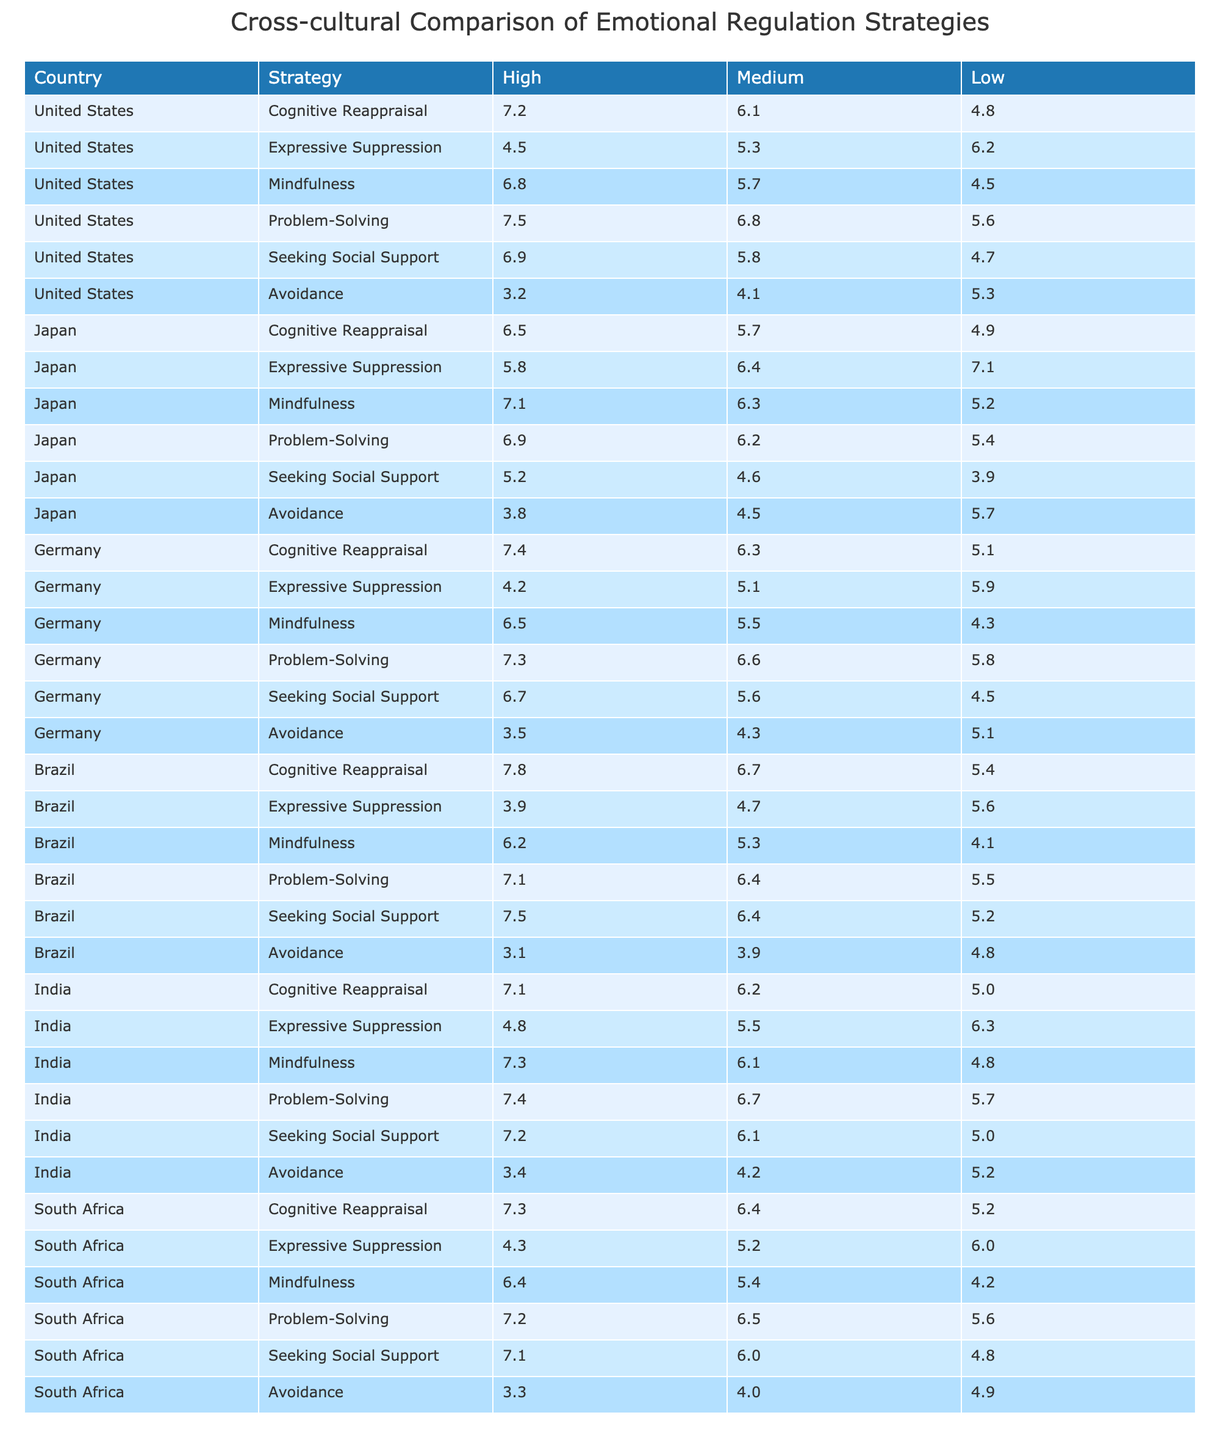What is the highest cognitive reappraisal score among countries for high empathy levels? The highest cognitive reappraisal score for high empathy is from Brazil with a score of 7.8.
Answer: 7.8 Which country shows the lowest score in expressive suppression for medium empathy? Japan has the lowest score in expressive suppression for medium empathy at 6.4.
Answer: 6.4 What is the average mindfulness score for high empathy across all countries? To find the average mindfulness score, add the high empathy scores: (6.8 + 7.1 + 6.5 + 6.2 + 7.3 + 7.8) = 41.7. Divide by 6: 41.7 / 6 = 6.95.
Answer: 6.95 Which emotional regulation strategy has the lowest average score for low empathy across all countries? For low empathy, the average scores are: Cognitive Reappraisal (5.1), Expressive Suppression (5.5), Mindfulness (4.9), Problem-Solving (5.3), Seeking Social Support (4.5), Avoidance (5.2). The lowest is Mindfulness at 4.9.
Answer: Mindfulness Is it true that Germany has a higher problem-solving score than the United States at medium empathy? Germany's medium problem-solving score is 6.6, while the United States' score is 6.8, which means it is false.
Answer: False What is the difference in seeking social support scores between high and low empathy for Brazil? For Brazil, high empathy seeking social support score is 7.5 and low empathy is 5.2. The difference is 7.5 - 5.2 = 2.3.
Answer: 2.3 Which country has the highest avoidance score for low empathy? For low empathy, the scores are: United States (5.3), Japan (5.7), Germany (5.1), Brazil (4.8), India (5.2), South Africa (4.9). Japan has the highest at 5.7.
Answer: Japan Is the average cognitive reappraisal score for high empathy higher or lower in South Africa compared to Japan? South Africa has a score of 7.3 and Japan has 6.5. Since 7.3 is higher than 6.5, the answer is higher.
Answer: Higher What strategy has the most consistent scores across empathy levels in the United States? Reviewing the United States scores: Cognitive Reappraisal (7.2, 6.1, 4.8), Expressive Suppression (4.5, 5.3, 6.2), Mindfulness (6.8, 5.7, 4.5), Problem-Solving (7.5, 6.8, 5.6), Seeking Social Support (6.9, 5.8, 4.7), Avoidance (3.2, 4.1, 5.3). Problem-Solving has relatively close scores (7.5, 6.8, 5.6), making it the most consistent.
Answer: Problem-Solving Which country shows the greatest change in cognitive reappraisal scores between high and low empathy? Evaluating the countries: United States (2.4), Japan (1.6), Germany (2.3), Brazil (2.4), India (2.1), South Africa (2.1). The United States and Brazil both show a change of 2.4, which is the greatest.
Answer: United States and Brazil 